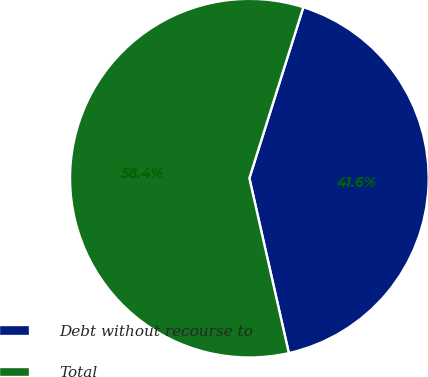Convert chart to OTSL. <chart><loc_0><loc_0><loc_500><loc_500><pie_chart><fcel>Debt without recourse to<fcel>Total<nl><fcel>41.6%<fcel>58.4%<nl></chart> 